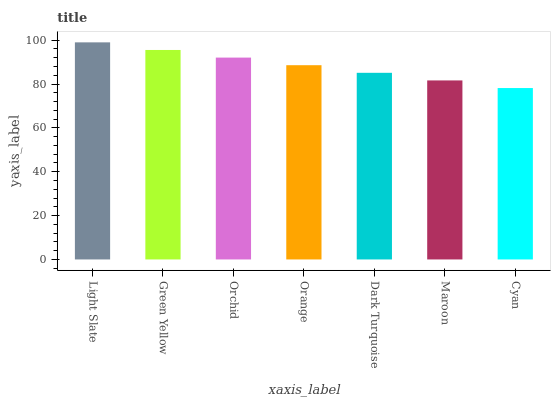Is Cyan the minimum?
Answer yes or no. Yes. Is Light Slate the maximum?
Answer yes or no. Yes. Is Green Yellow the minimum?
Answer yes or no. No. Is Green Yellow the maximum?
Answer yes or no. No. Is Light Slate greater than Green Yellow?
Answer yes or no. Yes. Is Green Yellow less than Light Slate?
Answer yes or no. Yes. Is Green Yellow greater than Light Slate?
Answer yes or no. No. Is Light Slate less than Green Yellow?
Answer yes or no. No. Is Orange the high median?
Answer yes or no. Yes. Is Orange the low median?
Answer yes or no. Yes. Is Dark Turquoise the high median?
Answer yes or no. No. Is Maroon the low median?
Answer yes or no. No. 